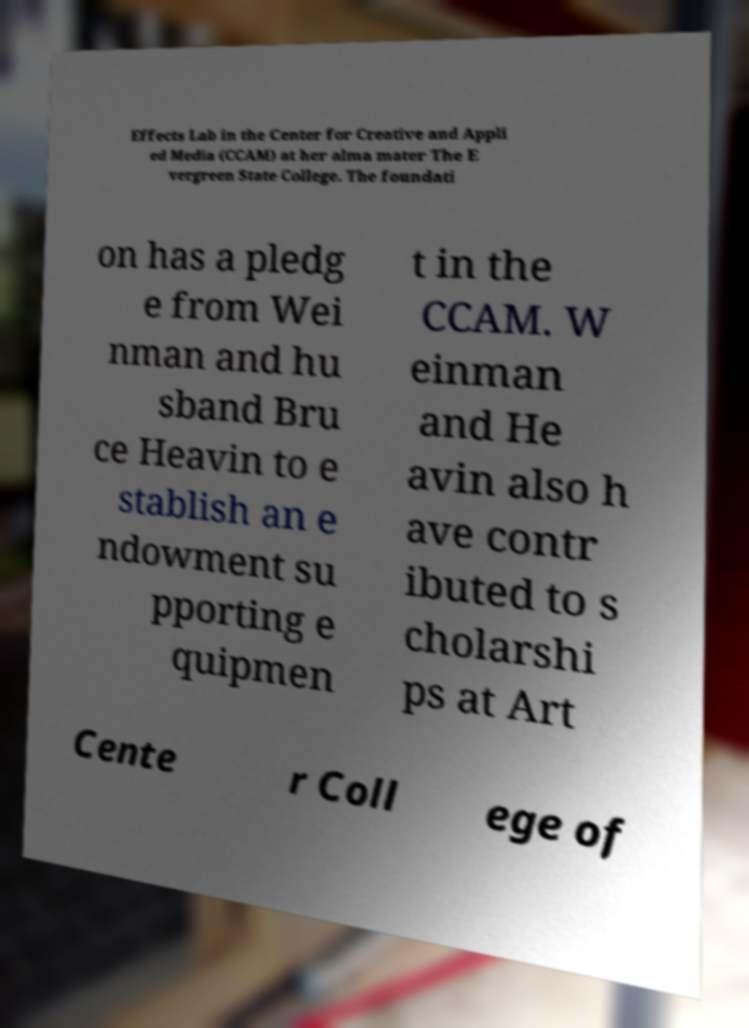Can you read and provide the text displayed in the image?This photo seems to have some interesting text. Can you extract and type it out for me? Effects Lab in the Center for Creative and Appli ed Media (CCAM) at her alma mater The E vergreen State College. The foundati on has a pledg e from Wei nman and hu sband Bru ce Heavin to e stablish an e ndowment su pporting e quipmen t in the CCAM. W einman and He avin also h ave contr ibuted to s cholarshi ps at Art Cente r Coll ege of 